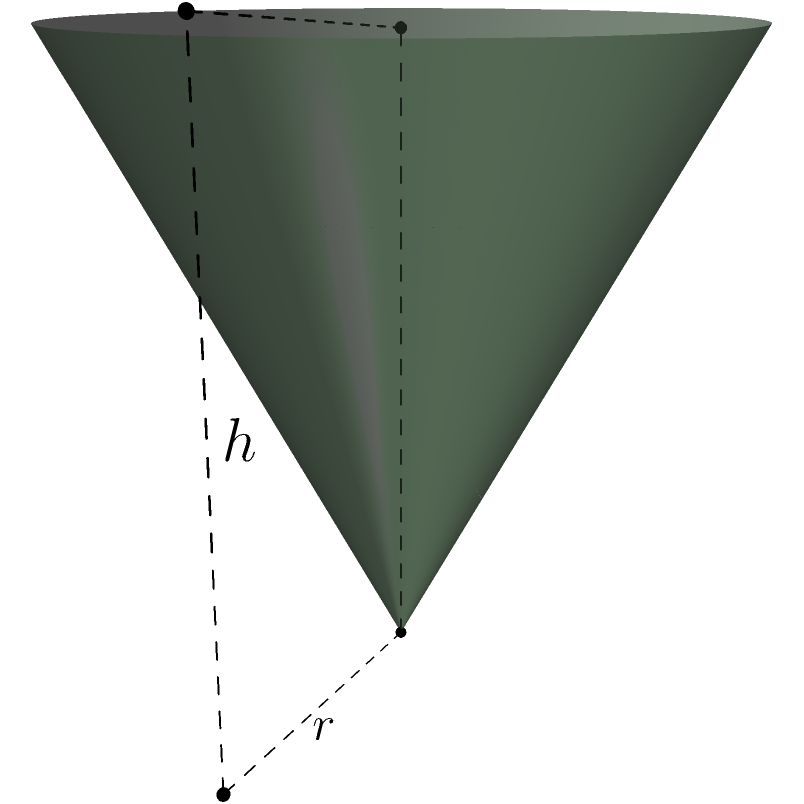As an environmentalist and resident of Eucalyptus Street, you've decided to create a mulch pile for community gardening. The conical pile has a radius of 3 meters at the base and a height of 4 meters. What is the volume of the mulch pile in cubic meters? To find the volume of a conical pile of mulch, we can use the formula for the volume of a cone:

$$ V = \frac{1}{3}\pi r^2 h $$

Where:
$V$ = volume
$r$ = radius of the base
$h$ = height of the cone

Given:
$r = 3$ meters
$h = 4$ meters

Let's substitute these values into the formula:

$$ V = \frac{1}{3}\pi (3\text{ m})^2 (4\text{ m}) $$

Simplifying:
$$ V = \frac{1}{3}\pi (9\text{ m}^2) (4\text{ m}) $$
$$ V = \frac{1}{3}\pi (36\text{ m}^3) $$
$$ V = 12\pi\text{ m}^3 $$

Calculating the final value (rounded to two decimal places):
$$ V \approx 37.70\text{ m}^3 $$

This volume represents the amount of mulch in the conical pile, which will be beneficial for the community garden's soil health and water retention.
Answer: $37.70\text{ m}^3$ 